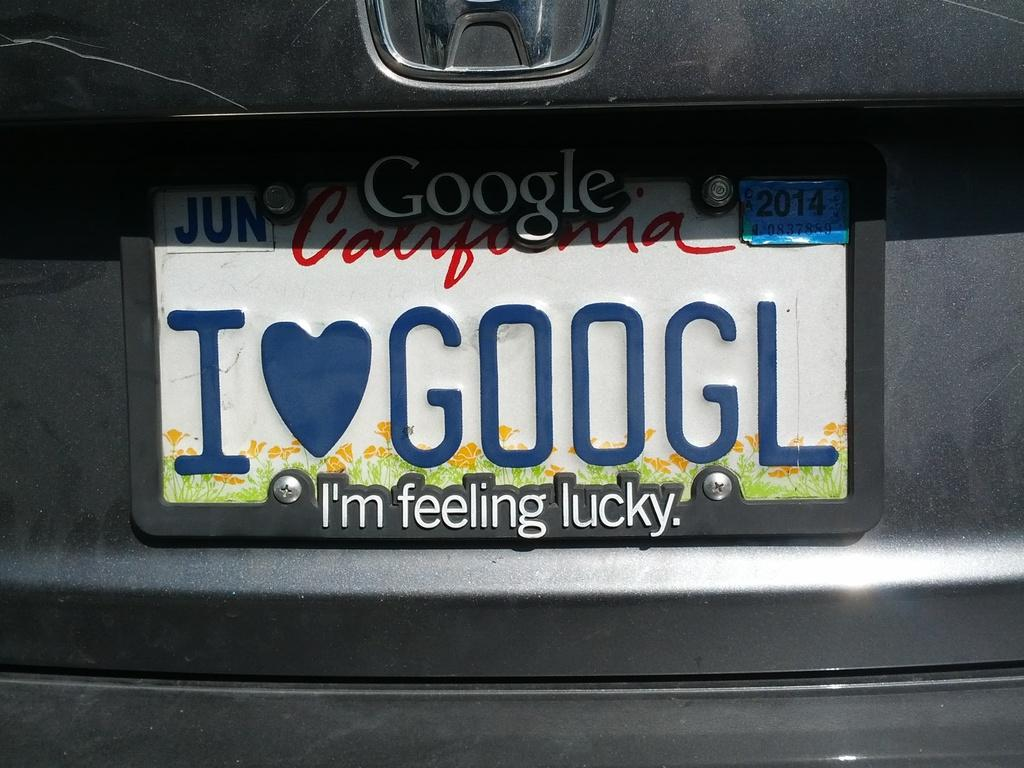Provide a one-sentence caption for the provided image. "I heart Googl" is being used on the rear license plate of this vehicle. 